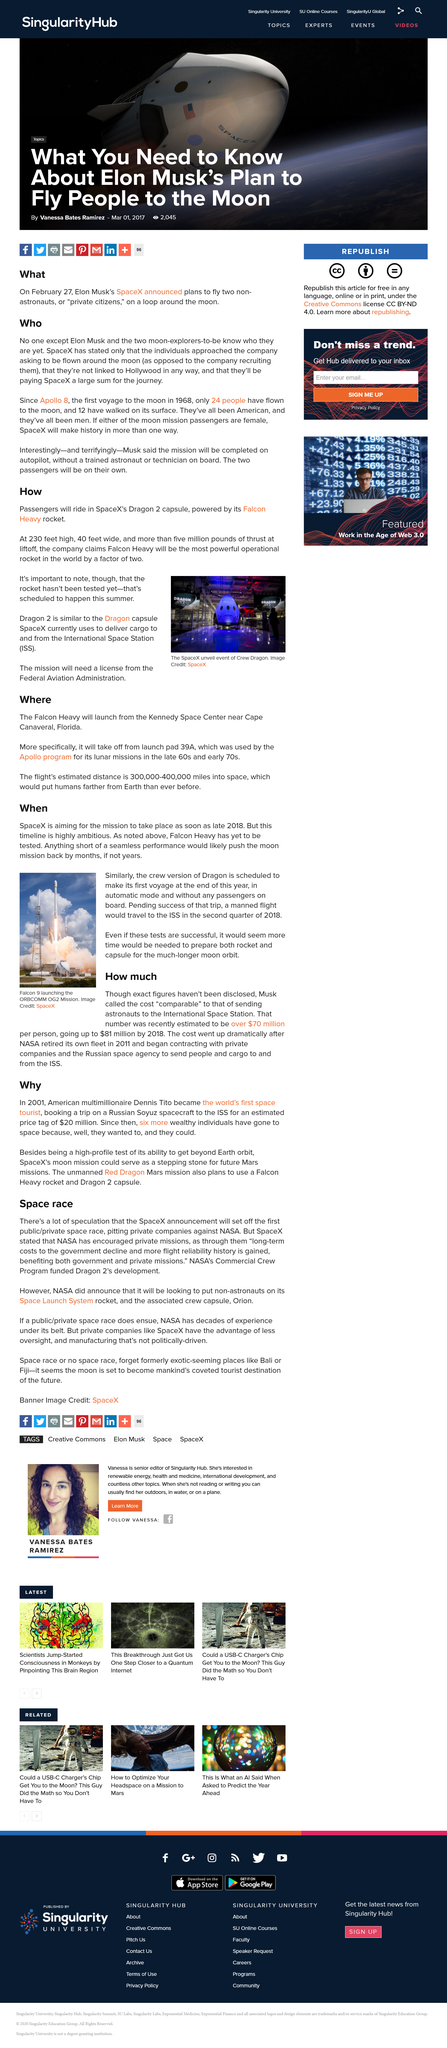Outline some significant characteristics in this image. Since the first voyage to the moon in 1968, 24 people have flown to the lunar surface. The first voyage to the moon was undertaken in 1968. The Falcon Heavy is the world's most powerful rocket, making it twice as powerful as any other rocket currently in existence. The article is about the space race, which is about space exploration and competition between different countries to achieve space milestones. The Dragon 2 capsule will carry passengers and supplies to and from the International Space Station. 